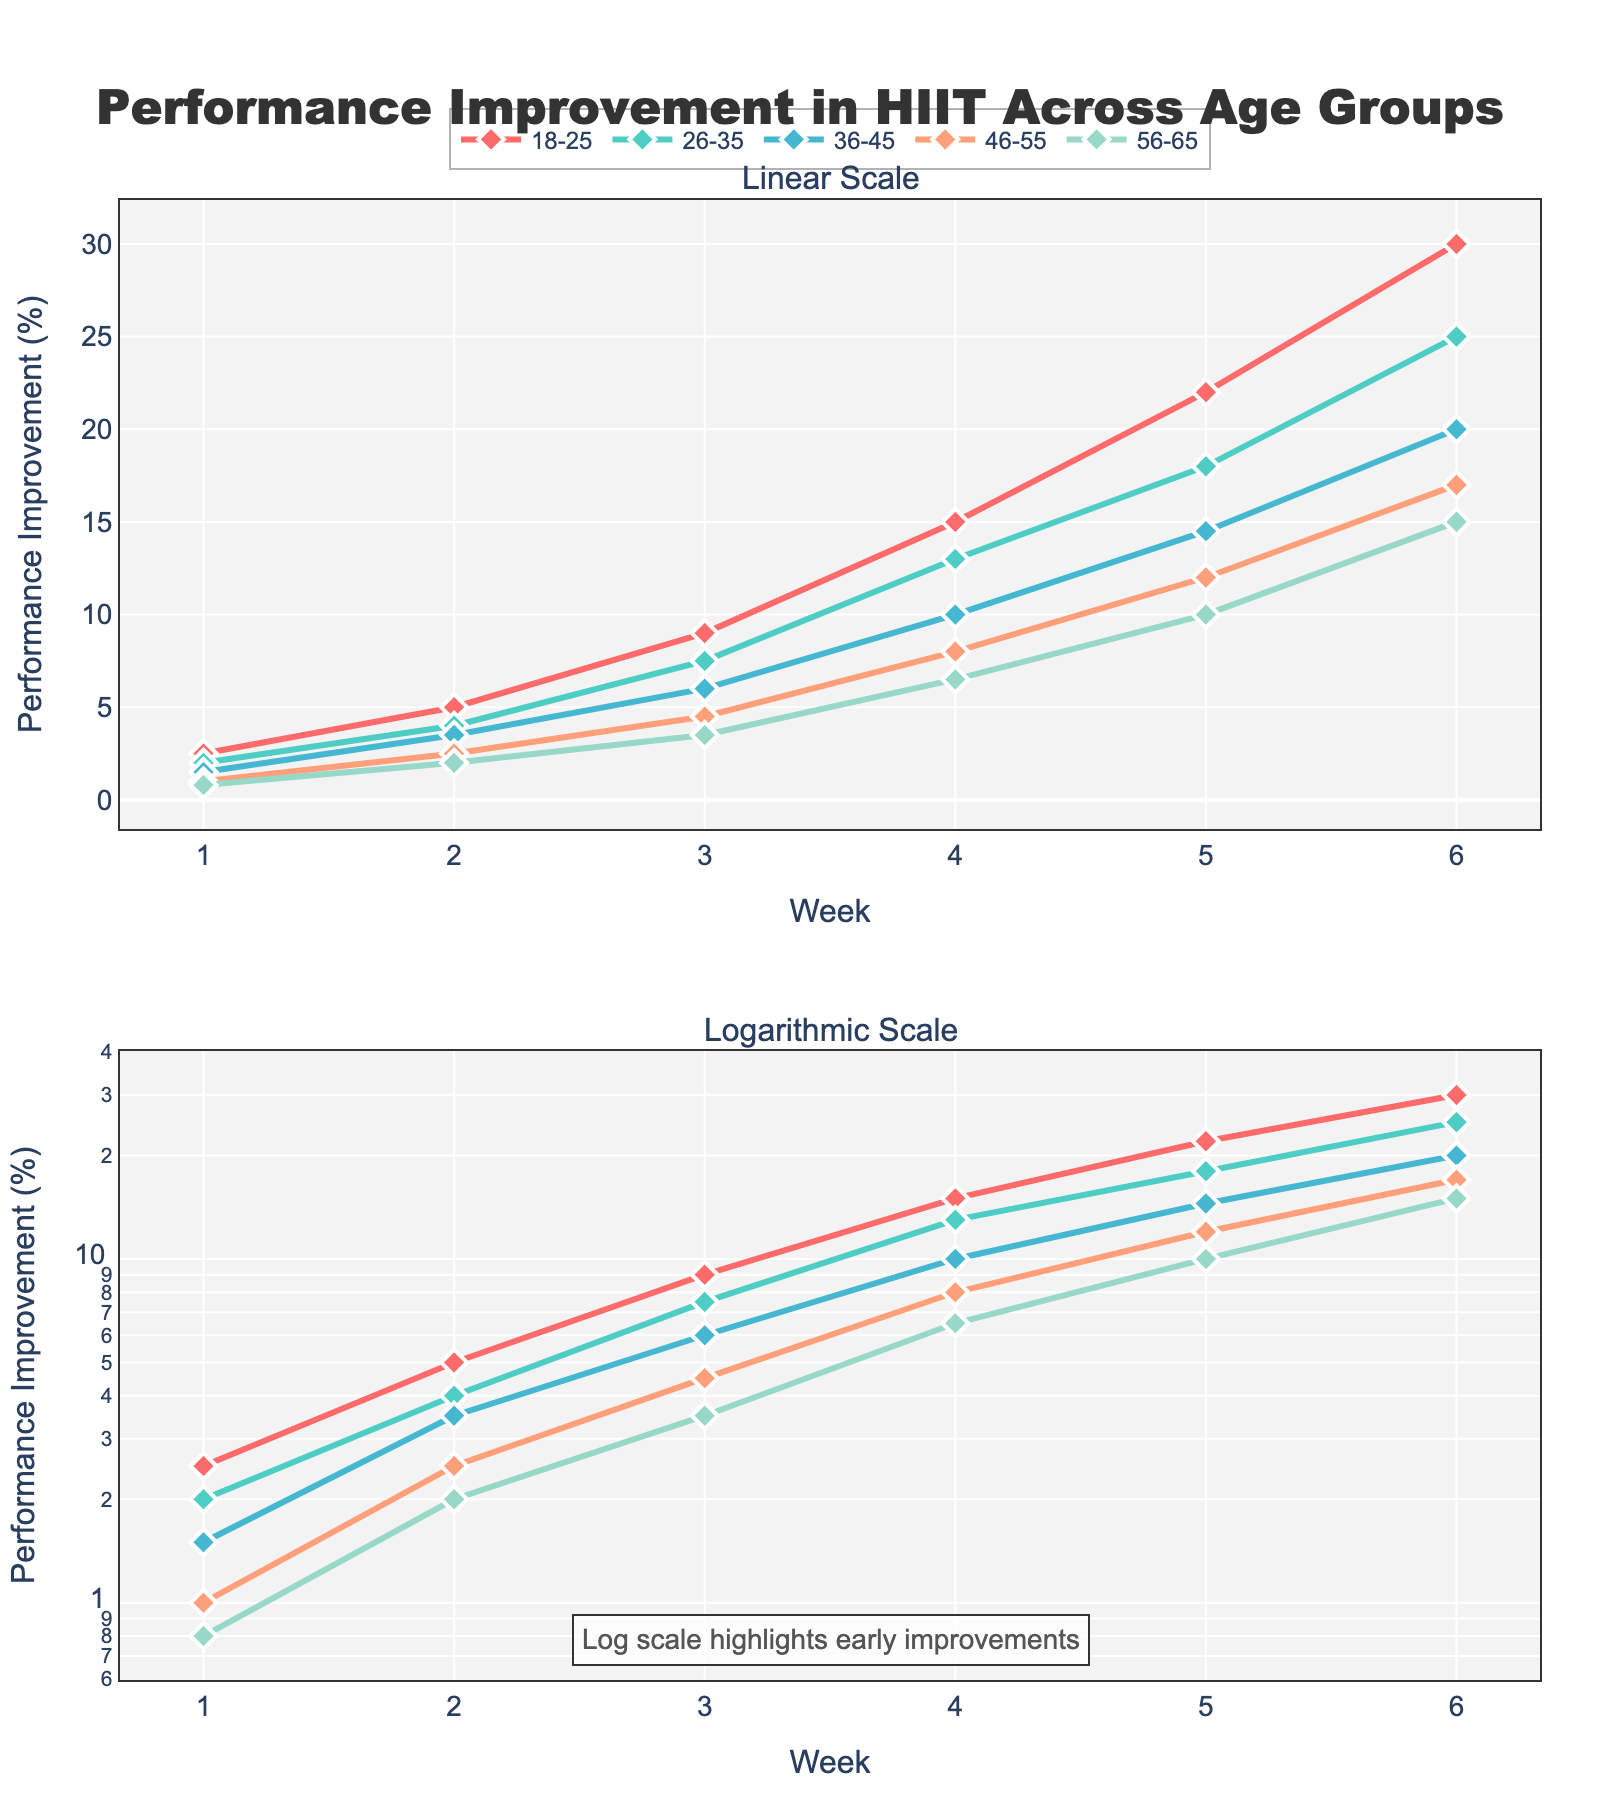How many weeks of performance data are presented in the figure? There are 6 weeks of performance improvement data for each age group, ranging from Week 1 to Week 6, as indicated on the x-axis of both subplots.
Answer: 6 What is the title of the figure? The title of the figure is displayed at the top and reads "Performance Improvement in HIIT Across Age Groups."
Answer: Performance Improvement in HIIT Across Age Groups Which age group shows the highest performance improvement in Week 6 in the linear scale subplot? In the linear scale subplot, the age group 18-25 shows the highest performance improvement in Week 6 with a value of 30%.
Answer: 18-25 How does the performance improvement trend differ between the 18-25 and 56-65 age groups in the log scale subplot? In the log scale subplot, the 18-25 age group shows a consistently steeper slope, indicating a faster rate of improvement over time compared to the 56-65 age group, which shows a more gradual increase.
Answer: 18-25 improves faster What is the general purpose of using a logarithmic scale in the second subplot? The general purpose of using a logarithmic scale in the second subplot is to highlight early improvements more effectively by spreading out values that would otherwise be compressed near the lower end of the scale on a linear plot.
Answer: Highlight early improvements On the linear scale subplot, which age group shows the least improvement by Week 3? On the linear scale subplot, the 56-65 age group shows the least improvement by Week 3 with a performance improvement of 3.5%.
Answer: 56-65 What is the coloration used to differentiate the age groups? Each age group is represented by a distinct color: 18-25 (red), 26-35 (cyan), 36-45 (blue), 46-55 (orange), and 56-65 (light green).
Answer: Different colors per age group Between which weeks does the 26-35 age group show the sharpest increase in performance improvement in the log scale subplot? In the log scale subplot, the 26-35 age group shows the sharpest increase in performance improvement between Weeks 3 and 4, where the performance improvement increases from 7.5% to 13%.
Answer: Weeks 3 and 4 How does the annotation at the bottom of the figure help in understanding the log scale subplot? The annotation at the bottom of the figure indicates that the log scale is used to highlight early improvements, which helps the viewer understand why the smaller improvements at the beginning are more visually separated in the log scale subplot.
Answer: It explains the purpose of the log scale 